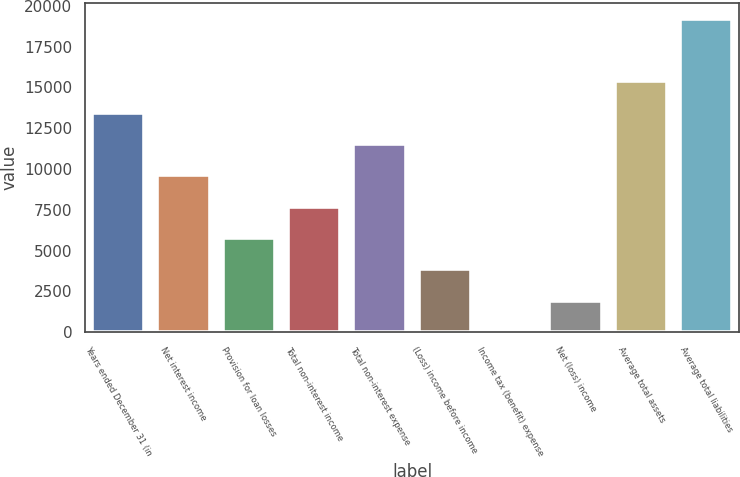Convert chart. <chart><loc_0><loc_0><loc_500><loc_500><bar_chart><fcel>Years ended December 31 (in<fcel>Net interest income<fcel>Provision for loan losses<fcel>Total non-interest income<fcel>Total non-interest expense<fcel>(Loss) income before income<fcel>Income tax (benefit) expense<fcel>Net (loss) income<fcel>Average total assets<fcel>Average total liabilities<nl><fcel>13445.6<fcel>9604.5<fcel>5763.38<fcel>7683.94<fcel>11525.1<fcel>3842.82<fcel>1.7<fcel>1922.26<fcel>15366.2<fcel>19207.3<nl></chart> 